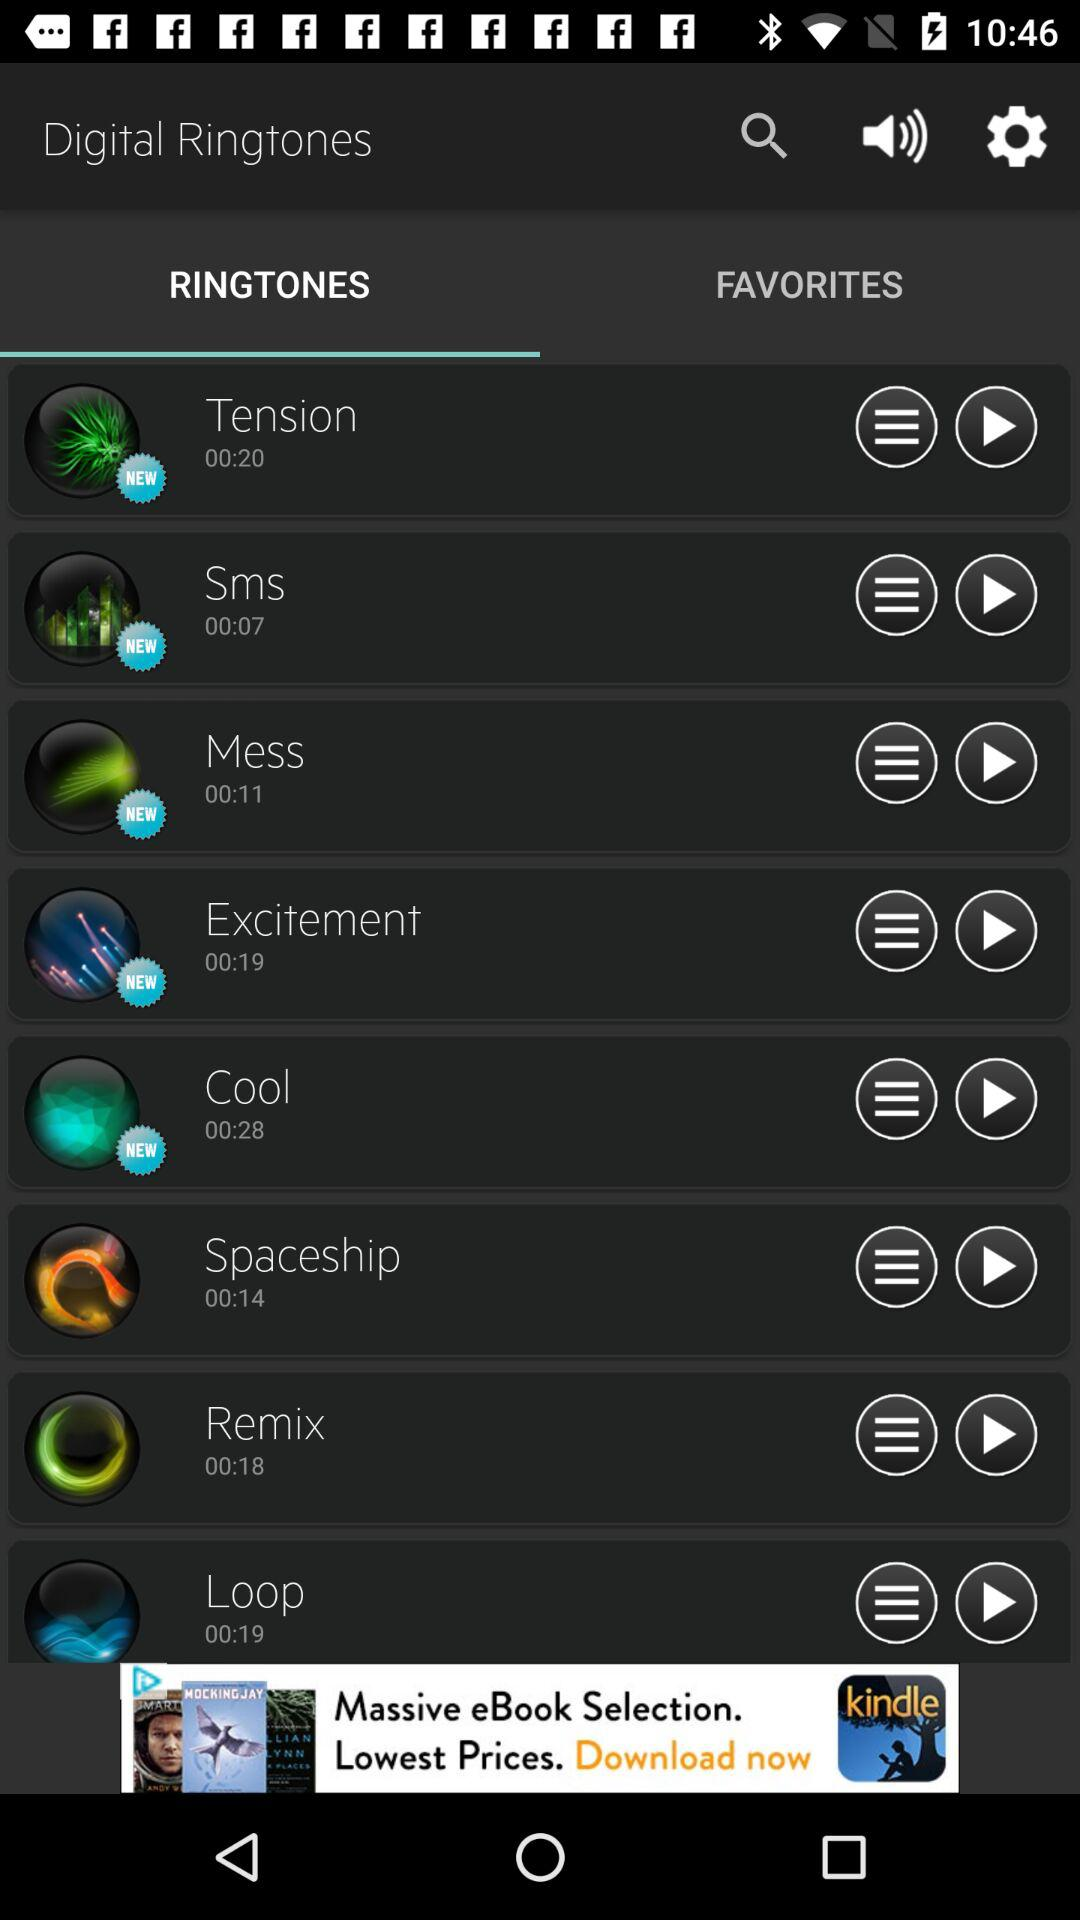How many items have a duration of less than 00:15?
Answer the question using a single word or phrase. 3 